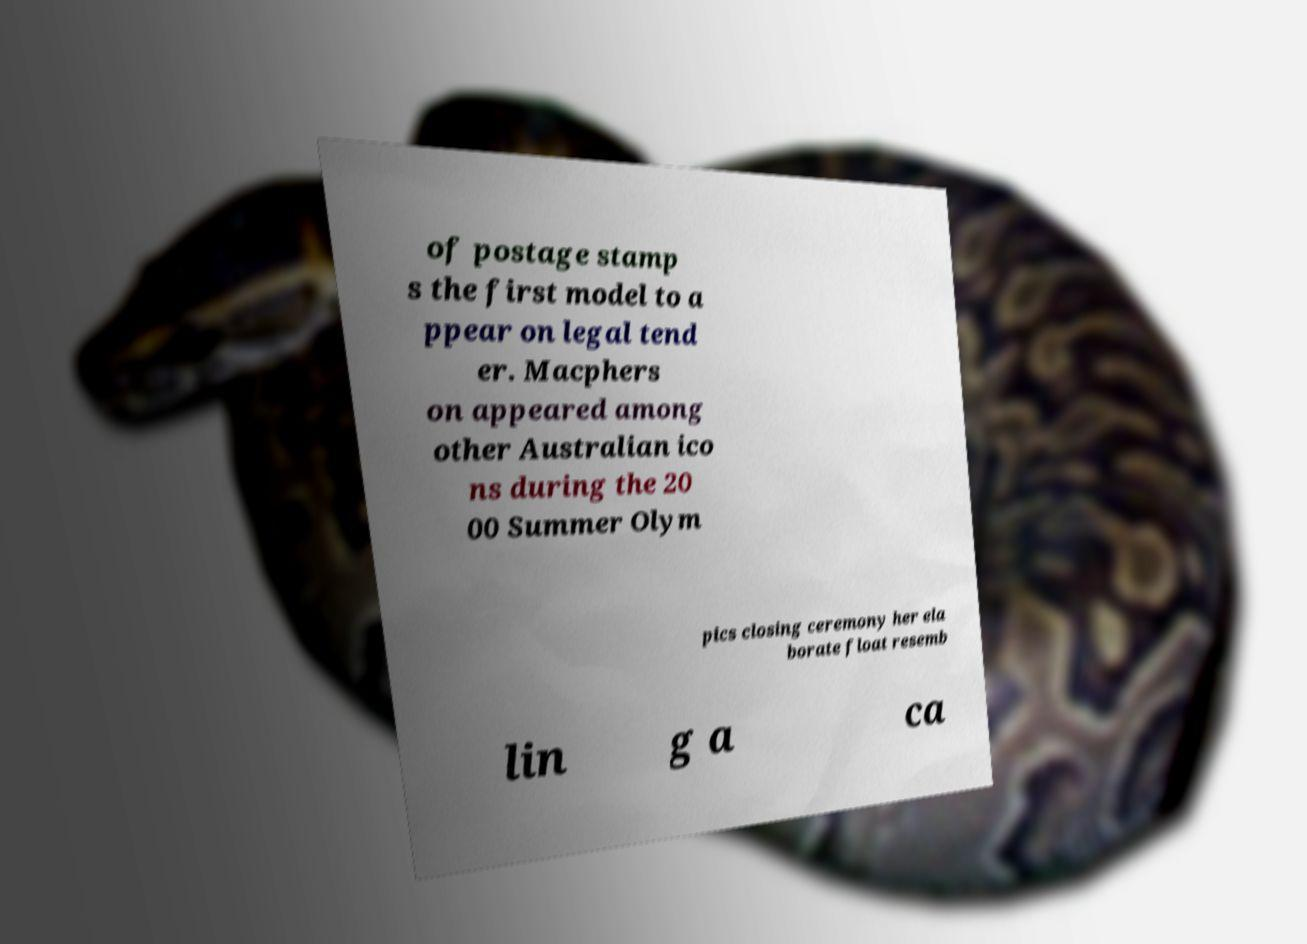Please identify and transcribe the text found in this image. of postage stamp s the first model to a ppear on legal tend er. Macphers on appeared among other Australian ico ns during the 20 00 Summer Olym pics closing ceremony her ela borate float resemb lin g a ca 